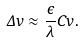<formula> <loc_0><loc_0><loc_500><loc_500>\Delta v \approx \frac { \epsilon } { \lambda } C v .</formula> 